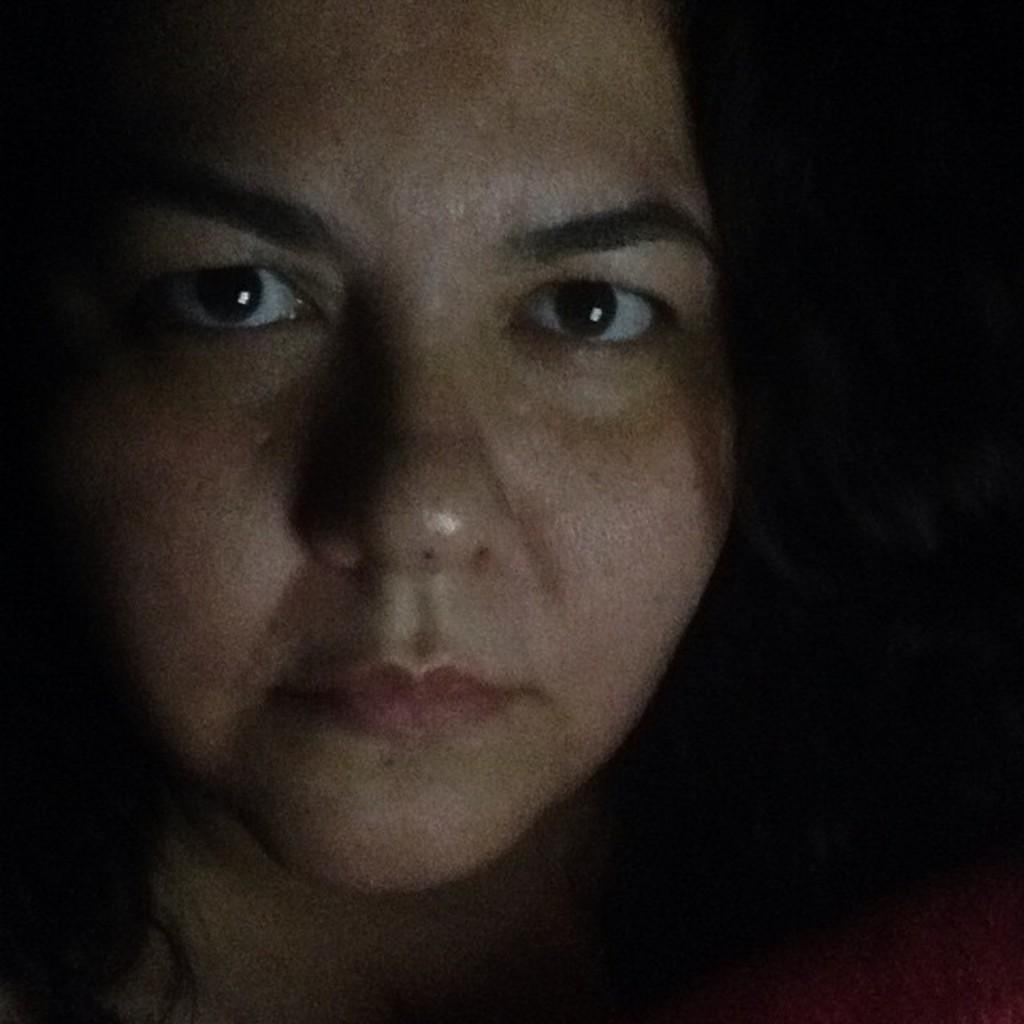Who is present in the image? There is a woman in the image. What can be observed about the background of the image? The background of the image is dark. What type of animals can be seen at the zoo in the image? There is no zoo present in the image, so it is not possible to determine what, if any, animals might be seen. 